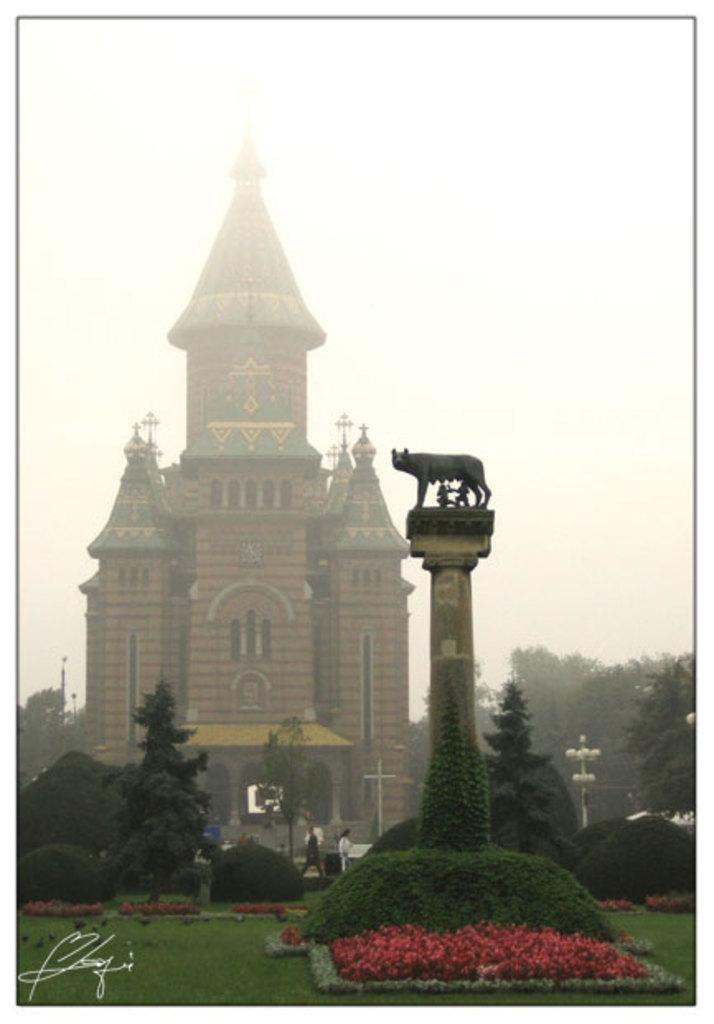What type of structure is visible in the image? There is a building in the image. What other natural elements can be seen in the image? There are trees in the image. Can you describe any decorative or artistic elements in the image? There is an animal sculpture on a pillar in the image. What type of produce is being harvested in the image? There is no produce or harvesting activity present in the image. 